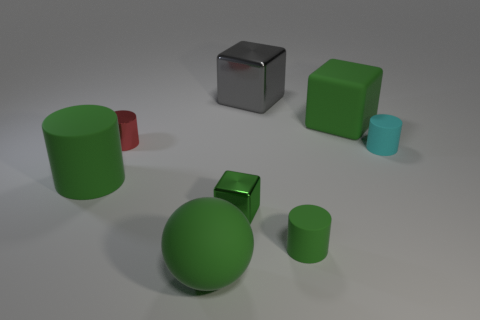Subtract 1 cylinders. How many cylinders are left? 3 Add 1 blue rubber blocks. How many objects exist? 9 Subtract all cubes. How many objects are left? 5 Add 7 tiny red matte cubes. How many tiny red matte cubes exist? 7 Subtract 0 purple spheres. How many objects are left? 8 Subtract all large yellow blocks. Subtract all cylinders. How many objects are left? 4 Add 6 big green cylinders. How many big green cylinders are left? 7 